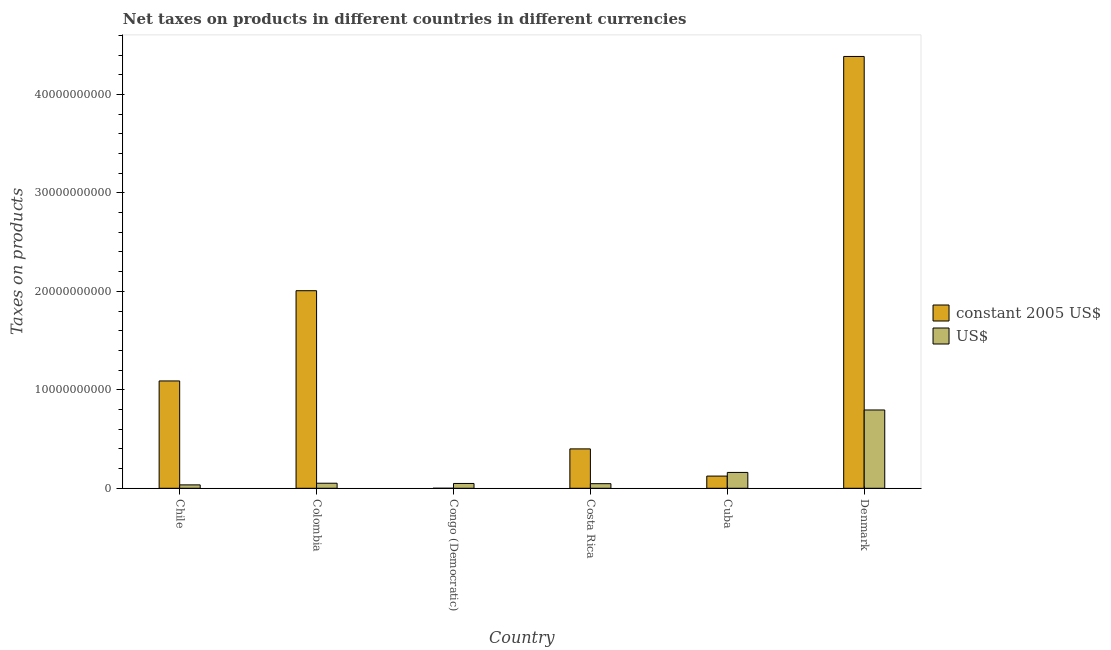How many different coloured bars are there?
Keep it short and to the point. 2. How many groups of bars are there?
Your answer should be compact. 6. How many bars are there on the 6th tick from the right?
Offer a terse response. 2. What is the net taxes in constant 2005 us$ in Denmark?
Make the answer very short. 4.39e+1. Across all countries, what is the maximum net taxes in constant 2005 us$?
Give a very brief answer. 4.39e+1. Across all countries, what is the minimum net taxes in constant 2005 us$?
Your answer should be compact. 0. What is the total net taxes in constant 2005 us$ in the graph?
Keep it short and to the point. 8.01e+1. What is the difference between the net taxes in us$ in Chile and that in Costa Rica?
Offer a terse response. -1.22e+08. What is the difference between the net taxes in us$ in Costa Rica and the net taxes in constant 2005 us$ in Colombia?
Your answer should be compact. -1.96e+1. What is the average net taxes in us$ per country?
Offer a very short reply. 1.90e+09. What is the difference between the net taxes in constant 2005 us$ and net taxes in us$ in Denmark?
Give a very brief answer. 3.59e+1. In how many countries, is the net taxes in constant 2005 us$ greater than 18000000000 units?
Ensure brevity in your answer.  2. What is the ratio of the net taxes in constant 2005 us$ in Chile to that in Cuba?
Provide a short and direct response. 8.8. Is the difference between the net taxes in constant 2005 us$ in Chile and Denmark greater than the difference between the net taxes in us$ in Chile and Denmark?
Your response must be concise. No. What is the difference between the highest and the second highest net taxes in us$?
Offer a terse response. 6.34e+09. What is the difference between the highest and the lowest net taxes in constant 2005 us$?
Keep it short and to the point. 4.39e+1. In how many countries, is the net taxes in constant 2005 us$ greater than the average net taxes in constant 2005 us$ taken over all countries?
Ensure brevity in your answer.  2. Is the sum of the net taxes in us$ in Chile and Colombia greater than the maximum net taxes in constant 2005 us$ across all countries?
Provide a short and direct response. No. What does the 1st bar from the left in Congo (Democratic) represents?
Give a very brief answer. Constant 2005 us$. What does the 1st bar from the right in Chile represents?
Your answer should be very brief. US$. How many bars are there?
Provide a short and direct response. 12. Are all the bars in the graph horizontal?
Your answer should be compact. No. What is the difference between two consecutive major ticks on the Y-axis?
Your answer should be very brief. 1.00e+1. Are the values on the major ticks of Y-axis written in scientific E-notation?
Your answer should be very brief. No. Does the graph contain grids?
Give a very brief answer. No. Where does the legend appear in the graph?
Provide a short and direct response. Center right. What is the title of the graph?
Give a very brief answer. Net taxes on products in different countries in different currencies. Does "Urban Population" appear as one of the legend labels in the graph?
Keep it short and to the point. No. What is the label or title of the X-axis?
Give a very brief answer. Country. What is the label or title of the Y-axis?
Provide a short and direct response. Taxes on products. What is the Taxes on products of constant 2005 US$ in Chile?
Provide a short and direct response. 1.09e+1. What is the Taxes on products of US$ in Chile?
Make the answer very short. 3.44e+08. What is the Taxes on products of constant 2005 US$ in Colombia?
Offer a very short reply. 2.01e+1. What is the Taxes on products of US$ in Colombia?
Ensure brevity in your answer.  5.13e+08. What is the Taxes on products in constant 2005 US$ in Congo (Democratic)?
Give a very brief answer. 0. What is the Taxes on products in US$ in Congo (Democratic)?
Give a very brief answer. 4.89e+08. What is the Taxes on products in constant 2005 US$ in Costa Rica?
Your answer should be compact. 4.00e+09. What is the Taxes on products in US$ in Costa Rica?
Provide a succinct answer. 4.67e+08. What is the Taxes on products in constant 2005 US$ in Cuba?
Ensure brevity in your answer.  1.24e+09. What is the Taxes on products of US$ in Cuba?
Offer a terse response. 1.61e+09. What is the Taxes on products in constant 2005 US$ in Denmark?
Your answer should be compact. 4.39e+1. What is the Taxes on products in US$ in Denmark?
Ensure brevity in your answer.  7.95e+09. Across all countries, what is the maximum Taxes on products in constant 2005 US$?
Provide a short and direct response. 4.39e+1. Across all countries, what is the maximum Taxes on products in US$?
Ensure brevity in your answer.  7.95e+09. Across all countries, what is the minimum Taxes on products in constant 2005 US$?
Your answer should be very brief. 0. Across all countries, what is the minimum Taxes on products in US$?
Provide a succinct answer. 3.44e+08. What is the total Taxes on products of constant 2005 US$ in the graph?
Offer a very short reply. 8.01e+1. What is the total Taxes on products of US$ in the graph?
Keep it short and to the point. 1.14e+1. What is the difference between the Taxes on products in constant 2005 US$ in Chile and that in Colombia?
Provide a succinct answer. -9.16e+09. What is the difference between the Taxes on products in US$ in Chile and that in Colombia?
Offer a very short reply. -1.69e+08. What is the difference between the Taxes on products in constant 2005 US$ in Chile and that in Congo (Democratic)?
Offer a terse response. 1.09e+1. What is the difference between the Taxes on products of US$ in Chile and that in Congo (Democratic)?
Make the answer very short. -1.45e+08. What is the difference between the Taxes on products of constant 2005 US$ in Chile and that in Costa Rica?
Offer a very short reply. 6.90e+09. What is the difference between the Taxes on products of US$ in Chile and that in Costa Rica?
Offer a terse response. -1.22e+08. What is the difference between the Taxes on products of constant 2005 US$ in Chile and that in Cuba?
Make the answer very short. 9.66e+09. What is the difference between the Taxes on products of US$ in Chile and that in Cuba?
Provide a succinct answer. -1.27e+09. What is the difference between the Taxes on products of constant 2005 US$ in Chile and that in Denmark?
Your answer should be very brief. -3.30e+1. What is the difference between the Taxes on products of US$ in Chile and that in Denmark?
Give a very brief answer. -7.61e+09. What is the difference between the Taxes on products in constant 2005 US$ in Colombia and that in Congo (Democratic)?
Provide a succinct answer. 2.01e+1. What is the difference between the Taxes on products of US$ in Colombia and that in Congo (Democratic)?
Your answer should be very brief. 2.41e+07. What is the difference between the Taxes on products of constant 2005 US$ in Colombia and that in Costa Rica?
Keep it short and to the point. 1.61e+1. What is the difference between the Taxes on products in US$ in Colombia and that in Costa Rica?
Your answer should be compact. 4.65e+07. What is the difference between the Taxes on products in constant 2005 US$ in Colombia and that in Cuba?
Offer a very short reply. 1.88e+1. What is the difference between the Taxes on products of US$ in Colombia and that in Cuba?
Give a very brief answer. -1.10e+09. What is the difference between the Taxes on products of constant 2005 US$ in Colombia and that in Denmark?
Give a very brief answer. -2.38e+1. What is the difference between the Taxes on products in US$ in Colombia and that in Denmark?
Keep it short and to the point. -7.44e+09. What is the difference between the Taxes on products in constant 2005 US$ in Congo (Democratic) and that in Costa Rica?
Give a very brief answer. -4.00e+09. What is the difference between the Taxes on products in US$ in Congo (Democratic) and that in Costa Rica?
Make the answer very short. 2.24e+07. What is the difference between the Taxes on products of constant 2005 US$ in Congo (Democratic) and that in Cuba?
Offer a terse response. -1.24e+09. What is the difference between the Taxes on products in US$ in Congo (Democratic) and that in Cuba?
Your answer should be very brief. -1.12e+09. What is the difference between the Taxes on products in constant 2005 US$ in Congo (Democratic) and that in Denmark?
Give a very brief answer. -4.39e+1. What is the difference between the Taxes on products of US$ in Congo (Democratic) and that in Denmark?
Ensure brevity in your answer.  -7.46e+09. What is the difference between the Taxes on products of constant 2005 US$ in Costa Rica and that in Cuba?
Your answer should be very brief. 2.76e+09. What is the difference between the Taxes on products in US$ in Costa Rica and that in Cuba?
Provide a succinct answer. -1.14e+09. What is the difference between the Taxes on products of constant 2005 US$ in Costa Rica and that in Denmark?
Your answer should be very brief. -3.99e+1. What is the difference between the Taxes on products in US$ in Costa Rica and that in Denmark?
Provide a short and direct response. -7.49e+09. What is the difference between the Taxes on products in constant 2005 US$ in Cuba and that in Denmark?
Your response must be concise. -4.26e+1. What is the difference between the Taxes on products in US$ in Cuba and that in Denmark?
Make the answer very short. -6.34e+09. What is the difference between the Taxes on products in constant 2005 US$ in Chile and the Taxes on products in US$ in Colombia?
Offer a very short reply. 1.04e+1. What is the difference between the Taxes on products of constant 2005 US$ in Chile and the Taxes on products of US$ in Congo (Democratic)?
Ensure brevity in your answer.  1.04e+1. What is the difference between the Taxes on products in constant 2005 US$ in Chile and the Taxes on products in US$ in Costa Rica?
Your answer should be very brief. 1.04e+1. What is the difference between the Taxes on products in constant 2005 US$ in Chile and the Taxes on products in US$ in Cuba?
Your response must be concise. 9.29e+09. What is the difference between the Taxes on products in constant 2005 US$ in Chile and the Taxes on products in US$ in Denmark?
Your response must be concise. 2.95e+09. What is the difference between the Taxes on products of constant 2005 US$ in Colombia and the Taxes on products of US$ in Congo (Democratic)?
Provide a short and direct response. 1.96e+1. What is the difference between the Taxes on products of constant 2005 US$ in Colombia and the Taxes on products of US$ in Costa Rica?
Make the answer very short. 1.96e+1. What is the difference between the Taxes on products of constant 2005 US$ in Colombia and the Taxes on products of US$ in Cuba?
Your answer should be compact. 1.85e+1. What is the difference between the Taxes on products of constant 2005 US$ in Colombia and the Taxes on products of US$ in Denmark?
Your response must be concise. 1.21e+1. What is the difference between the Taxes on products of constant 2005 US$ in Congo (Democratic) and the Taxes on products of US$ in Costa Rica?
Your answer should be compact. -4.67e+08. What is the difference between the Taxes on products of constant 2005 US$ in Congo (Democratic) and the Taxes on products of US$ in Cuba?
Offer a terse response. -1.61e+09. What is the difference between the Taxes on products in constant 2005 US$ in Congo (Democratic) and the Taxes on products in US$ in Denmark?
Your answer should be compact. -7.95e+09. What is the difference between the Taxes on products in constant 2005 US$ in Costa Rica and the Taxes on products in US$ in Cuba?
Give a very brief answer. 2.39e+09. What is the difference between the Taxes on products in constant 2005 US$ in Costa Rica and the Taxes on products in US$ in Denmark?
Your response must be concise. -3.95e+09. What is the difference between the Taxes on products of constant 2005 US$ in Cuba and the Taxes on products of US$ in Denmark?
Provide a succinct answer. -6.71e+09. What is the average Taxes on products of constant 2005 US$ per country?
Offer a very short reply. 1.33e+1. What is the average Taxes on products of US$ per country?
Ensure brevity in your answer.  1.90e+09. What is the difference between the Taxes on products in constant 2005 US$ and Taxes on products in US$ in Chile?
Offer a terse response. 1.06e+1. What is the difference between the Taxes on products in constant 2005 US$ and Taxes on products in US$ in Colombia?
Ensure brevity in your answer.  1.96e+1. What is the difference between the Taxes on products of constant 2005 US$ and Taxes on products of US$ in Congo (Democratic)?
Offer a very short reply. -4.89e+08. What is the difference between the Taxes on products in constant 2005 US$ and Taxes on products in US$ in Costa Rica?
Offer a very short reply. 3.53e+09. What is the difference between the Taxes on products of constant 2005 US$ and Taxes on products of US$ in Cuba?
Your answer should be compact. -3.70e+08. What is the difference between the Taxes on products in constant 2005 US$ and Taxes on products in US$ in Denmark?
Provide a succinct answer. 3.59e+1. What is the ratio of the Taxes on products in constant 2005 US$ in Chile to that in Colombia?
Ensure brevity in your answer.  0.54. What is the ratio of the Taxes on products of US$ in Chile to that in Colombia?
Provide a short and direct response. 0.67. What is the ratio of the Taxes on products in constant 2005 US$ in Chile to that in Congo (Democratic)?
Ensure brevity in your answer.  8.00e+12. What is the ratio of the Taxes on products in US$ in Chile to that in Congo (Democratic)?
Provide a succinct answer. 0.7. What is the ratio of the Taxes on products of constant 2005 US$ in Chile to that in Costa Rica?
Give a very brief answer. 2.73. What is the ratio of the Taxes on products in US$ in Chile to that in Costa Rica?
Give a very brief answer. 0.74. What is the ratio of the Taxes on products of constant 2005 US$ in Chile to that in Cuba?
Offer a terse response. 8.8. What is the ratio of the Taxes on products in US$ in Chile to that in Cuba?
Offer a terse response. 0.21. What is the ratio of the Taxes on products of constant 2005 US$ in Chile to that in Denmark?
Your answer should be very brief. 0.25. What is the ratio of the Taxes on products of US$ in Chile to that in Denmark?
Provide a succinct answer. 0.04. What is the ratio of the Taxes on products in constant 2005 US$ in Colombia to that in Congo (Democratic)?
Provide a succinct answer. 1.47e+13. What is the ratio of the Taxes on products in US$ in Colombia to that in Congo (Democratic)?
Ensure brevity in your answer.  1.05. What is the ratio of the Taxes on products in constant 2005 US$ in Colombia to that in Costa Rica?
Your answer should be compact. 5.02. What is the ratio of the Taxes on products in US$ in Colombia to that in Costa Rica?
Your answer should be compact. 1.1. What is the ratio of the Taxes on products of constant 2005 US$ in Colombia to that in Cuba?
Your response must be concise. 16.19. What is the ratio of the Taxes on products in US$ in Colombia to that in Cuba?
Your response must be concise. 0.32. What is the ratio of the Taxes on products in constant 2005 US$ in Colombia to that in Denmark?
Your answer should be compact. 0.46. What is the ratio of the Taxes on products of US$ in Colombia to that in Denmark?
Ensure brevity in your answer.  0.06. What is the ratio of the Taxes on products in constant 2005 US$ in Congo (Democratic) to that in Costa Rica?
Your answer should be compact. 0. What is the ratio of the Taxes on products in US$ in Congo (Democratic) to that in Costa Rica?
Your answer should be compact. 1.05. What is the ratio of the Taxes on products of US$ in Congo (Democratic) to that in Cuba?
Provide a short and direct response. 0.3. What is the ratio of the Taxes on products in constant 2005 US$ in Congo (Democratic) to that in Denmark?
Your answer should be compact. 0. What is the ratio of the Taxes on products in US$ in Congo (Democratic) to that in Denmark?
Your response must be concise. 0.06. What is the ratio of the Taxes on products in constant 2005 US$ in Costa Rica to that in Cuba?
Make the answer very short. 3.23. What is the ratio of the Taxes on products of US$ in Costa Rica to that in Cuba?
Provide a succinct answer. 0.29. What is the ratio of the Taxes on products of constant 2005 US$ in Costa Rica to that in Denmark?
Offer a very short reply. 0.09. What is the ratio of the Taxes on products in US$ in Costa Rica to that in Denmark?
Offer a terse response. 0.06. What is the ratio of the Taxes on products in constant 2005 US$ in Cuba to that in Denmark?
Offer a terse response. 0.03. What is the ratio of the Taxes on products of US$ in Cuba to that in Denmark?
Your response must be concise. 0.2. What is the difference between the highest and the second highest Taxes on products in constant 2005 US$?
Offer a terse response. 2.38e+1. What is the difference between the highest and the second highest Taxes on products of US$?
Your answer should be compact. 6.34e+09. What is the difference between the highest and the lowest Taxes on products in constant 2005 US$?
Make the answer very short. 4.39e+1. What is the difference between the highest and the lowest Taxes on products of US$?
Provide a succinct answer. 7.61e+09. 